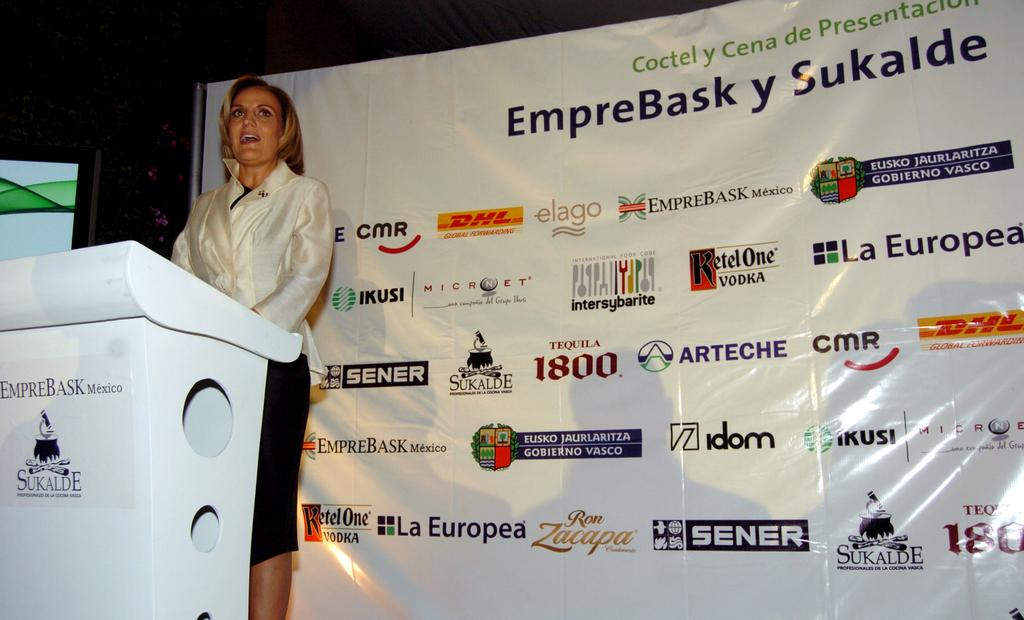Who is the main subject in the image? There is a woman in the image. What is the woman doing in the image? The woman is standing and talking. What is in front of the woman? There is a podium in front of the woman. What color is the podium? The podium is white in color. What is visible behind the woman? There is a banner behind the woman. Reasoning: Let's think step by step by step in order to produce the conversation. We start by identifying the main subject in the image, which is the woman. Then, we describe her actions and the objects around her, such as the podium and banner. Each question is designed to elicit a specific detail about the image that is known from the provided facts. Absurd Question/Answer: What type of eggnog is the woman drinking in the image? There is no eggnog present in the image; the woman is talking and standing near a podium. Can you see any teeth on the pig in the image? There is no pig present in the image, and therefore no teeth can be observed. 